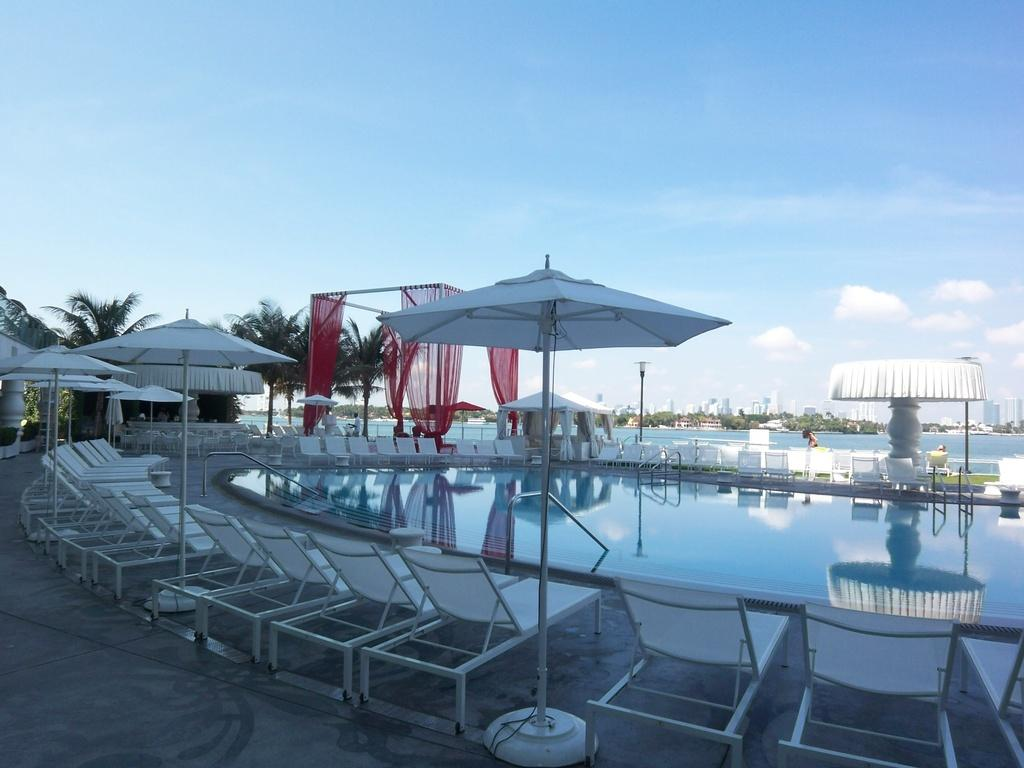What is the main feature of the image? There is a swimming pool in the image. What type of furniture is present near the swimming pool? Beach beds are present in the image. What provides shade in the image? Umbrellas are visible in the image. What type of vegetation is in the image? Trees are in the image. How would you describe the sky in the image? The sky is blue with clouds. What type of mint is growing near the swimming pool in the image? There is no mint present in the image. Can you see a kitty playing near the beach beds in the image? There is no kitty present in the image. 